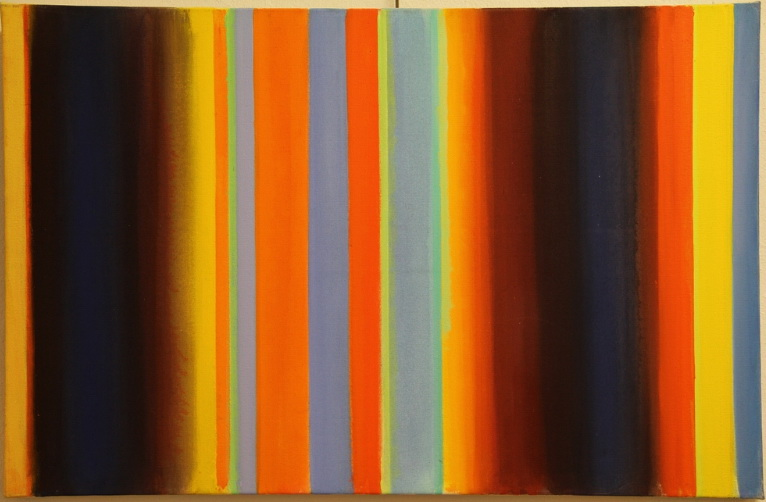What does the choice of colors in the painting suggest about the mood or theme of the artwork? The artist's selection of warm colors such as orange and yellow, contrasted with the calming tones of blue and the stark black, suggests a thematic exploration of opposition and harmony. This palette could be interpreted as symbolizing the dynamic interplay between warmth and coolness, light and shadow, or even chaos and order, offering a visual representation of balance and emotion. 